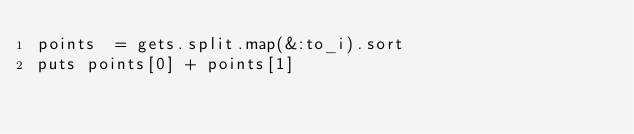<code> <loc_0><loc_0><loc_500><loc_500><_Ruby_>points  = gets.split.map(&:to_i).sort
puts points[0] + points[1]</code> 